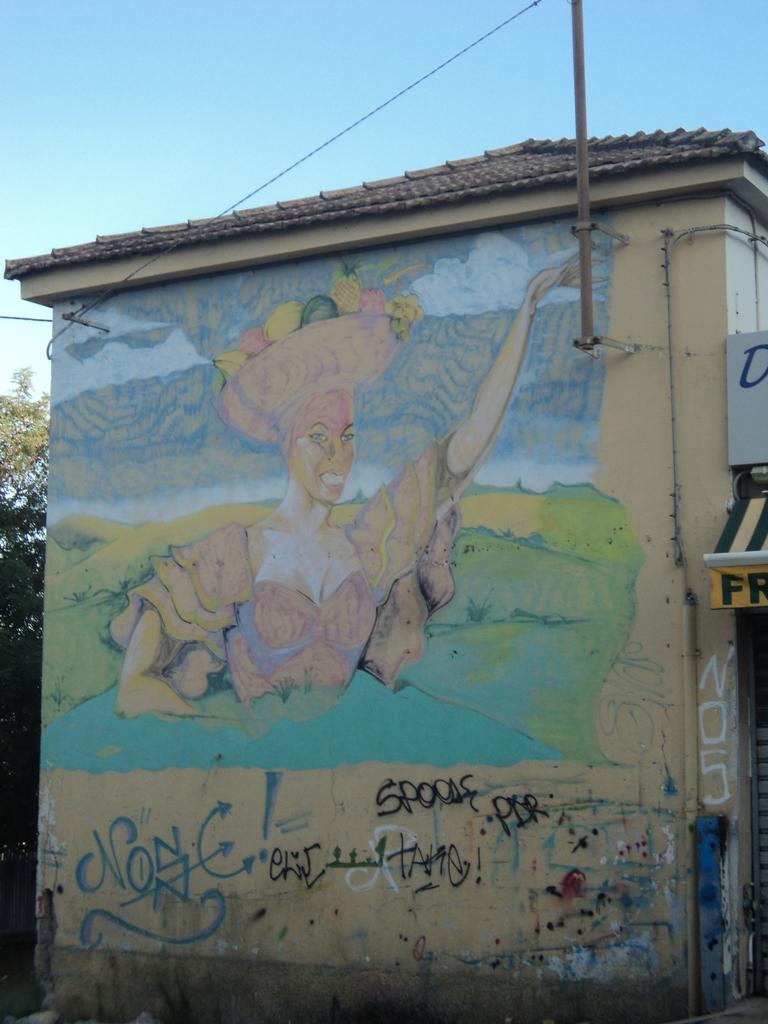How would you summarize this image in a sentence or two? In this image we can see the house. And we can see some painting on the house. And we can see one pole. And we can see electrical wires. And we can see texts written on the house. And we can see trees. And we can see the sky. we can one board with written text. 